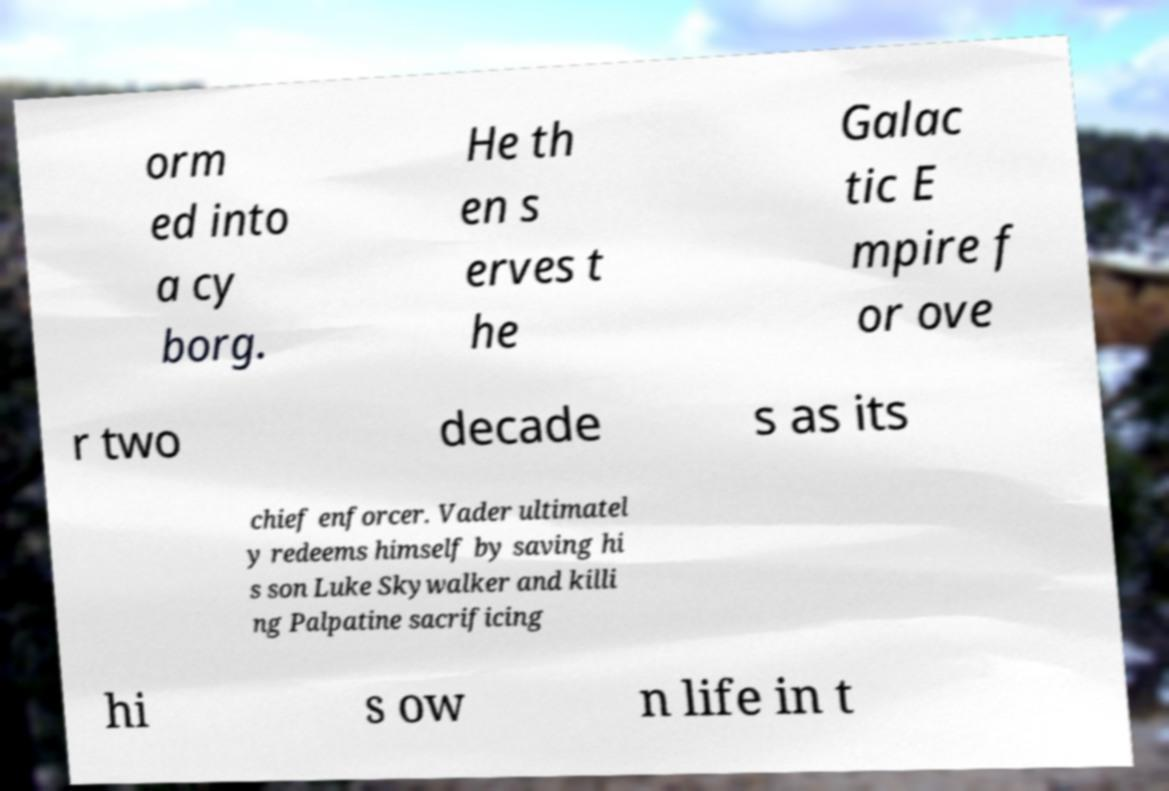Can you accurately transcribe the text from the provided image for me? orm ed into a cy borg. He th en s erves t he Galac tic E mpire f or ove r two decade s as its chief enforcer. Vader ultimatel y redeems himself by saving hi s son Luke Skywalker and killi ng Palpatine sacrificing hi s ow n life in t 